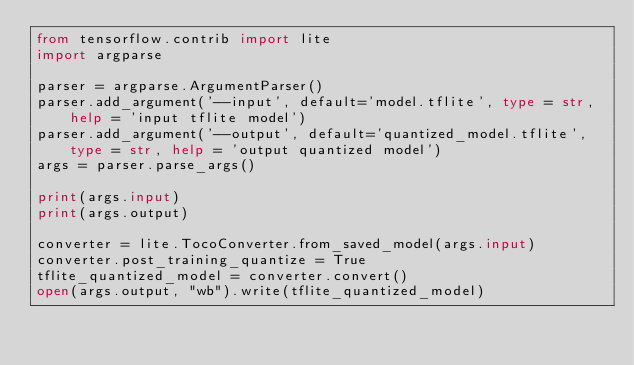Convert code to text. <code><loc_0><loc_0><loc_500><loc_500><_Python_>from tensorflow.contrib import lite
import argparse

parser = argparse.ArgumentParser()
parser.add_argument('--input', default='model.tflite', type = str, help = 'input tflite model')
parser.add_argument('--output', default='quantized_model.tflite', type = str, help = 'output quantized model')
args = parser.parse_args()

print(args.input)
print(args.output)

converter = lite.TocoConverter.from_saved_model(args.input)
converter.post_training_quantize = True
tflite_quantized_model = converter.convert()
open(args.output, "wb").write(tflite_quantized_model)
</code> 